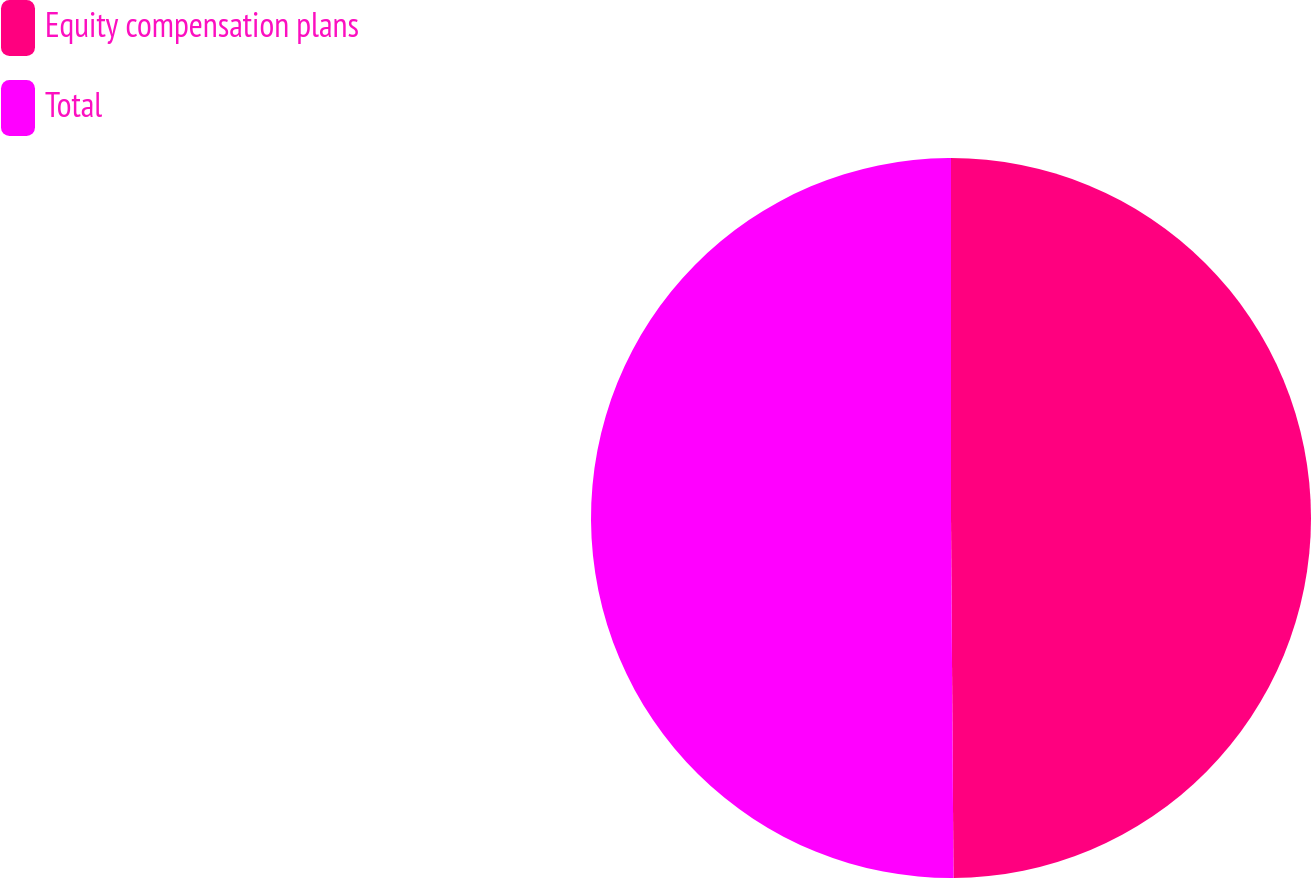<chart> <loc_0><loc_0><loc_500><loc_500><pie_chart><fcel>Equity compensation plans<fcel>Total<nl><fcel>49.89%<fcel>50.11%<nl></chart> 